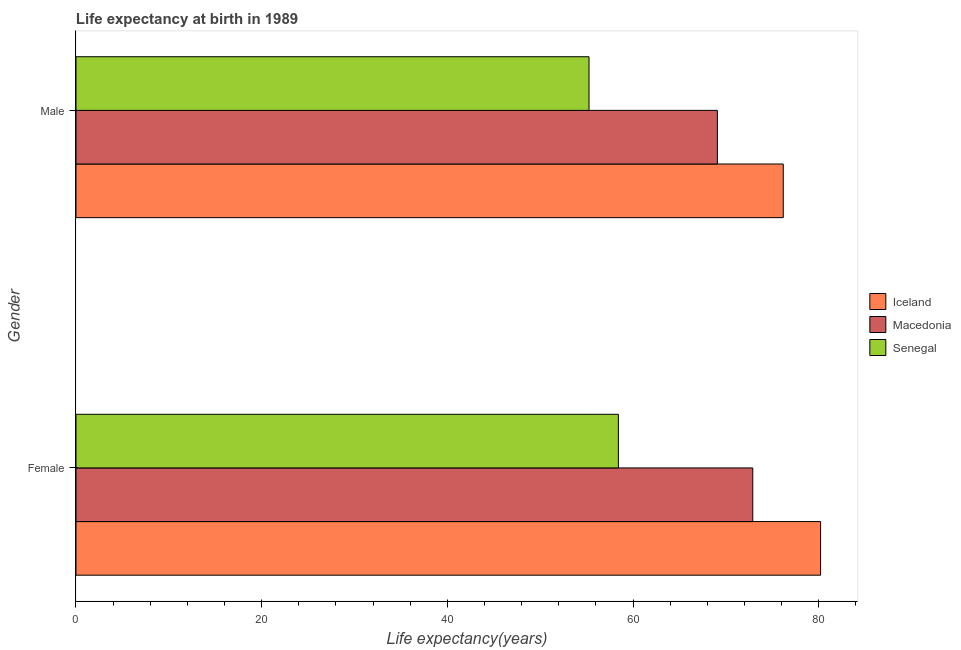How many groups of bars are there?
Offer a terse response. 2. How many bars are there on the 2nd tick from the top?
Ensure brevity in your answer.  3. How many bars are there on the 1st tick from the bottom?
Give a very brief answer. 3. What is the life expectancy(male) in Senegal?
Give a very brief answer. 55.26. Across all countries, what is the maximum life expectancy(male)?
Your answer should be very brief. 76.18. Across all countries, what is the minimum life expectancy(female)?
Your answer should be very brief. 58.42. In which country was the life expectancy(male) minimum?
Your response must be concise. Senegal. What is the total life expectancy(female) in the graph?
Give a very brief answer. 211.52. What is the difference between the life expectancy(female) in Macedonia and that in Senegal?
Your answer should be compact. 14.47. What is the difference between the life expectancy(female) in Iceland and the life expectancy(male) in Macedonia?
Your answer should be compact. 11.12. What is the average life expectancy(male) per country?
Give a very brief answer. 66.84. What is the difference between the life expectancy(female) and life expectancy(male) in Senegal?
Provide a short and direct response. 3.16. What is the ratio of the life expectancy(female) in Senegal to that in Macedonia?
Ensure brevity in your answer.  0.8. What does the 1st bar from the top in Female represents?
Give a very brief answer. Senegal. What does the 2nd bar from the bottom in Female represents?
Provide a succinct answer. Macedonia. How many bars are there?
Your answer should be compact. 6. What is the difference between two consecutive major ticks on the X-axis?
Provide a succinct answer. 20. Are the values on the major ticks of X-axis written in scientific E-notation?
Make the answer very short. No. Does the graph contain any zero values?
Offer a very short reply. No. Does the graph contain grids?
Give a very brief answer. No. Where does the legend appear in the graph?
Ensure brevity in your answer.  Center right. How many legend labels are there?
Your answer should be very brief. 3. How are the legend labels stacked?
Your answer should be compact. Vertical. What is the title of the graph?
Keep it short and to the point. Life expectancy at birth in 1989. Does "Guinea" appear as one of the legend labels in the graph?
Give a very brief answer. No. What is the label or title of the X-axis?
Make the answer very short. Life expectancy(years). What is the label or title of the Y-axis?
Your answer should be very brief. Gender. What is the Life expectancy(years) in Iceland in Female?
Your answer should be compact. 80.2. What is the Life expectancy(years) in Macedonia in Female?
Offer a terse response. 72.89. What is the Life expectancy(years) of Senegal in Female?
Offer a terse response. 58.42. What is the Life expectancy(years) of Iceland in Male?
Give a very brief answer. 76.18. What is the Life expectancy(years) of Macedonia in Male?
Give a very brief answer. 69.08. What is the Life expectancy(years) in Senegal in Male?
Make the answer very short. 55.26. Across all Gender, what is the maximum Life expectancy(years) of Iceland?
Your answer should be compact. 80.2. Across all Gender, what is the maximum Life expectancy(years) in Macedonia?
Give a very brief answer. 72.89. Across all Gender, what is the maximum Life expectancy(years) of Senegal?
Provide a succinct answer. 58.42. Across all Gender, what is the minimum Life expectancy(years) of Iceland?
Ensure brevity in your answer.  76.18. Across all Gender, what is the minimum Life expectancy(years) of Macedonia?
Give a very brief answer. 69.08. Across all Gender, what is the minimum Life expectancy(years) in Senegal?
Ensure brevity in your answer.  55.26. What is the total Life expectancy(years) in Iceland in the graph?
Keep it short and to the point. 156.38. What is the total Life expectancy(years) of Macedonia in the graph?
Give a very brief answer. 141.98. What is the total Life expectancy(years) in Senegal in the graph?
Offer a terse response. 113.68. What is the difference between the Life expectancy(years) of Iceland in Female and that in Male?
Ensure brevity in your answer.  4.02. What is the difference between the Life expectancy(years) of Macedonia in Female and that in Male?
Offer a terse response. 3.81. What is the difference between the Life expectancy(years) in Senegal in Female and that in Male?
Make the answer very short. 3.17. What is the difference between the Life expectancy(years) in Iceland in Female and the Life expectancy(years) in Macedonia in Male?
Provide a short and direct response. 11.12. What is the difference between the Life expectancy(years) in Iceland in Female and the Life expectancy(years) in Senegal in Male?
Provide a succinct answer. 24.94. What is the difference between the Life expectancy(years) of Macedonia in Female and the Life expectancy(years) of Senegal in Male?
Provide a succinct answer. 17.64. What is the average Life expectancy(years) in Iceland per Gender?
Give a very brief answer. 78.19. What is the average Life expectancy(years) of Macedonia per Gender?
Provide a succinct answer. 70.99. What is the average Life expectancy(years) of Senegal per Gender?
Your answer should be compact. 56.84. What is the difference between the Life expectancy(years) in Iceland and Life expectancy(years) in Macedonia in Female?
Keep it short and to the point. 7.3. What is the difference between the Life expectancy(years) in Iceland and Life expectancy(years) in Senegal in Female?
Make the answer very short. 21.78. What is the difference between the Life expectancy(years) in Macedonia and Life expectancy(years) in Senegal in Female?
Your answer should be compact. 14.47. What is the difference between the Life expectancy(years) of Iceland and Life expectancy(years) of Macedonia in Male?
Your answer should be very brief. 7.1. What is the difference between the Life expectancy(years) of Iceland and Life expectancy(years) of Senegal in Male?
Make the answer very short. 20.92. What is the difference between the Life expectancy(years) of Macedonia and Life expectancy(years) of Senegal in Male?
Make the answer very short. 13.82. What is the ratio of the Life expectancy(years) in Iceland in Female to that in Male?
Offer a very short reply. 1.05. What is the ratio of the Life expectancy(years) of Macedonia in Female to that in Male?
Ensure brevity in your answer.  1.06. What is the ratio of the Life expectancy(years) of Senegal in Female to that in Male?
Provide a short and direct response. 1.06. What is the difference between the highest and the second highest Life expectancy(years) in Iceland?
Your answer should be very brief. 4.02. What is the difference between the highest and the second highest Life expectancy(years) of Macedonia?
Make the answer very short. 3.81. What is the difference between the highest and the second highest Life expectancy(years) of Senegal?
Your answer should be very brief. 3.17. What is the difference between the highest and the lowest Life expectancy(years) in Iceland?
Give a very brief answer. 4.02. What is the difference between the highest and the lowest Life expectancy(years) in Macedonia?
Give a very brief answer. 3.81. What is the difference between the highest and the lowest Life expectancy(years) of Senegal?
Give a very brief answer. 3.17. 